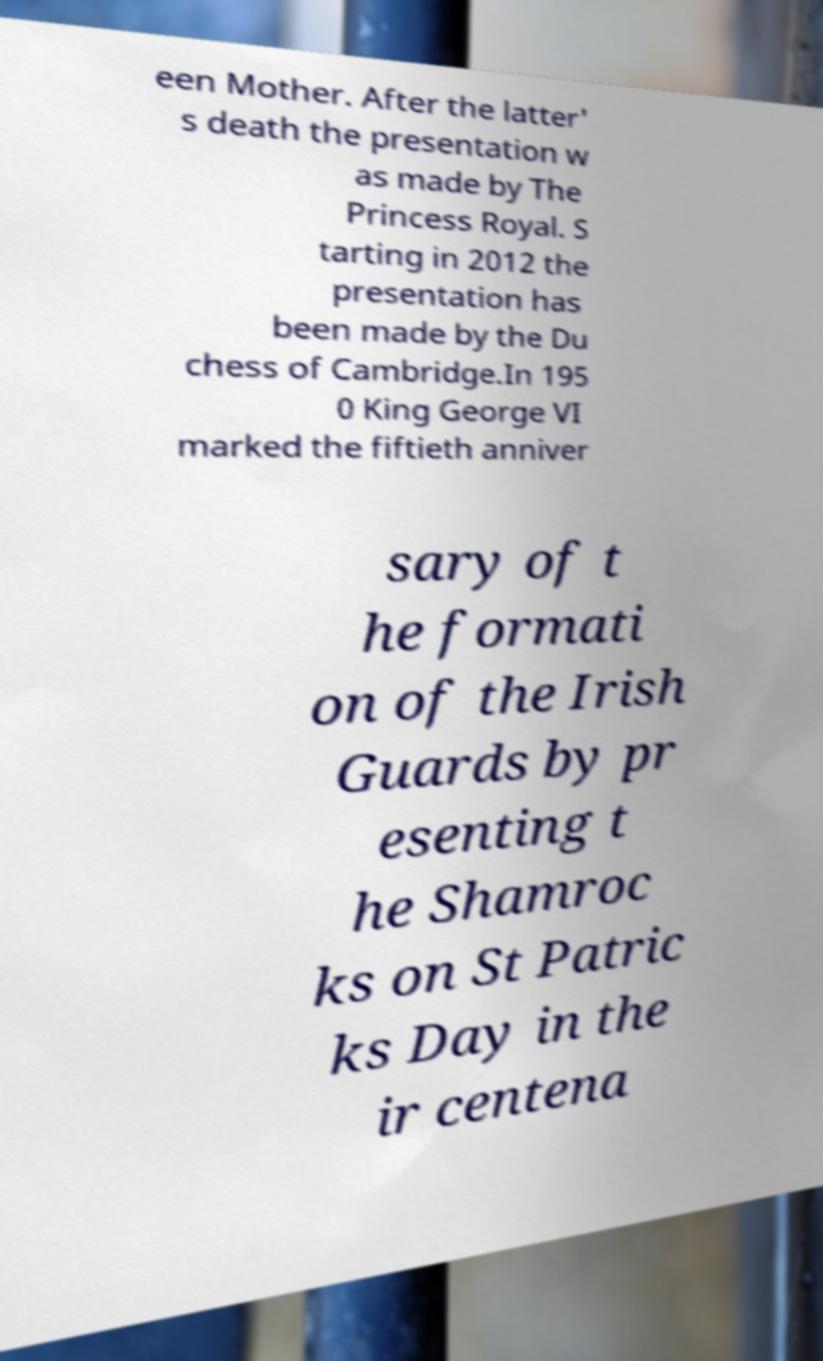There's text embedded in this image that I need extracted. Can you transcribe it verbatim? een Mother. After the latter' s death the presentation w as made by The Princess Royal. S tarting in 2012 the presentation has been made by the Du chess of Cambridge.In 195 0 King George VI marked the fiftieth anniver sary of t he formati on of the Irish Guards by pr esenting t he Shamroc ks on St Patric ks Day in the ir centena 